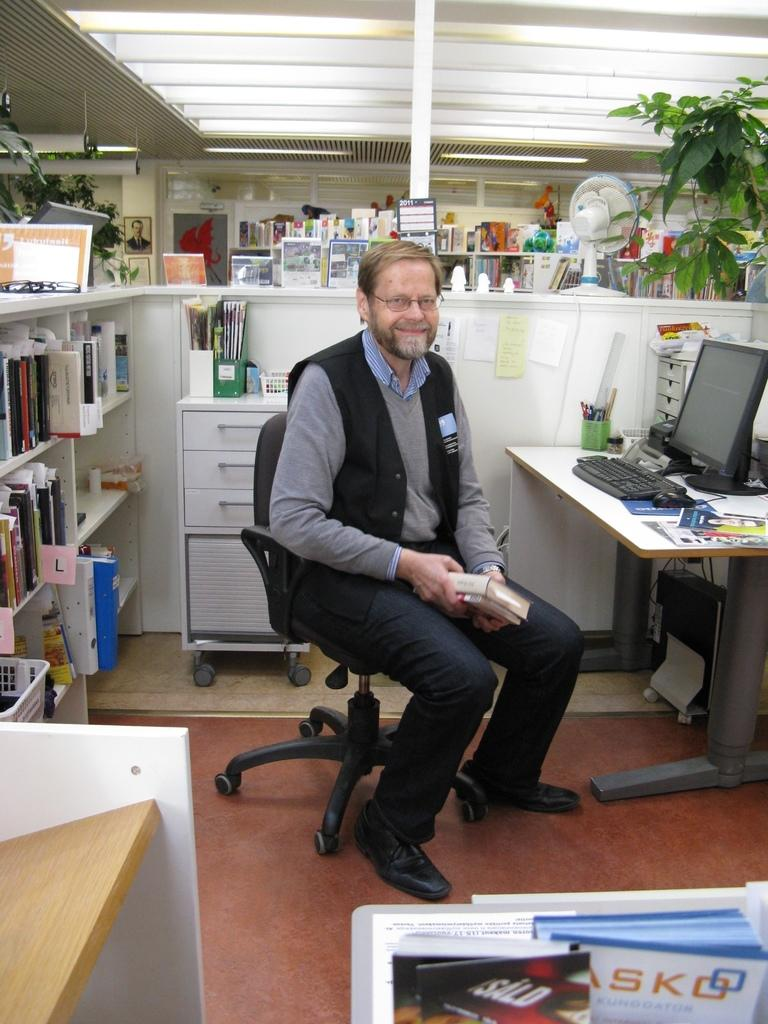<image>
Provide a brief description of the given image. a man at his desk with a calendar behind him for 2011 